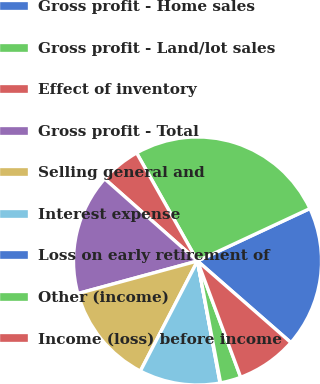Convert chart. <chart><loc_0><loc_0><loc_500><loc_500><pie_chart><fcel>Gross profit - Home sales<fcel>Gross profit - Land/lot sales<fcel>Effect of inventory<fcel>Gross profit - Total<fcel>Selling general and<fcel>Interest expense<fcel>Loss on early retirement of<fcel>Other (income)<fcel>Income (loss) before income<nl><fcel>18.38%<fcel>26.22%<fcel>5.3%<fcel>15.76%<fcel>13.15%<fcel>10.53%<fcel>0.07%<fcel>2.68%<fcel>7.91%<nl></chart> 